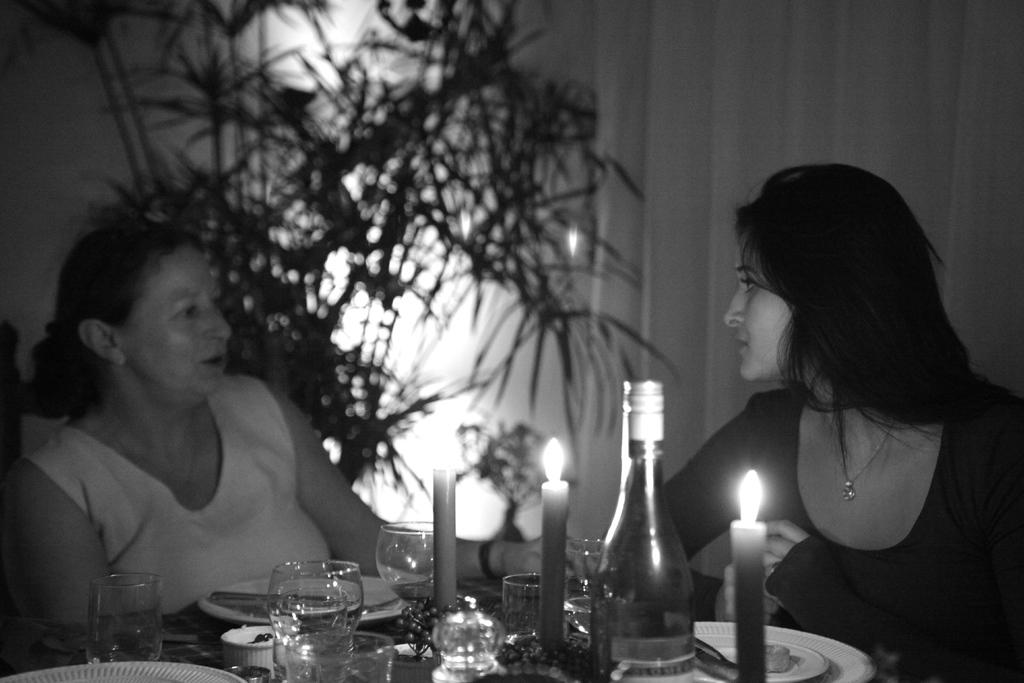How many people are sitting in the image? There are two women sitting in the image. What objects can be seen on the table? There is a bottle, a glass, a plate, and a candle on the table. What might be used for drinking in the image? The glass on the table might be used for drinking. What might be used for eating in the image? The plate on the table might be used for eating. How many clocks are visible on the table in the image? There are no clocks visible on the table in the image. 